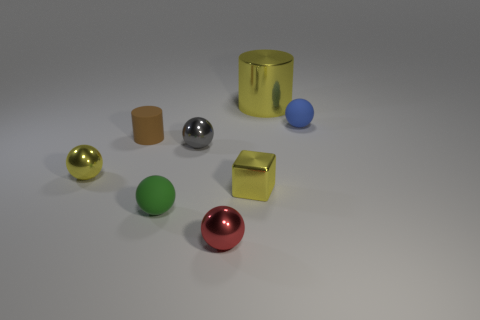There is a gray ball; is it the same size as the matte ball that is on the left side of the small blue rubber ball?
Your answer should be very brief. Yes. There is a small thing that is both to the right of the red metal object and in front of the tiny gray object; what is its color?
Your answer should be compact. Yellow. Is the number of green balls in front of the green matte thing greater than the number of blue matte balls that are behind the red metallic ball?
Provide a succinct answer. No. What is the size of the yellow block that is the same material as the small gray thing?
Your answer should be compact. Small. There is a ball that is behind the brown rubber object; how many small spheres are left of it?
Your response must be concise. 4. Are there any tiny green objects of the same shape as the big metal object?
Give a very brief answer. No. There is a matte ball that is in front of the tiny rubber ball behind the yellow shiny ball; what is its color?
Keep it short and to the point. Green. Are there more small brown matte things than tiny things?
Your answer should be compact. No. What number of blue matte objects have the same size as the rubber cylinder?
Ensure brevity in your answer.  1. Do the blue thing and the small yellow thing on the left side of the small rubber cylinder have the same material?
Ensure brevity in your answer.  No. 